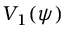Convert formula to latex. <formula><loc_0><loc_0><loc_500><loc_500>V _ { 1 } ( \psi )</formula> 